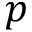<formula> <loc_0><loc_0><loc_500><loc_500>p</formula> 